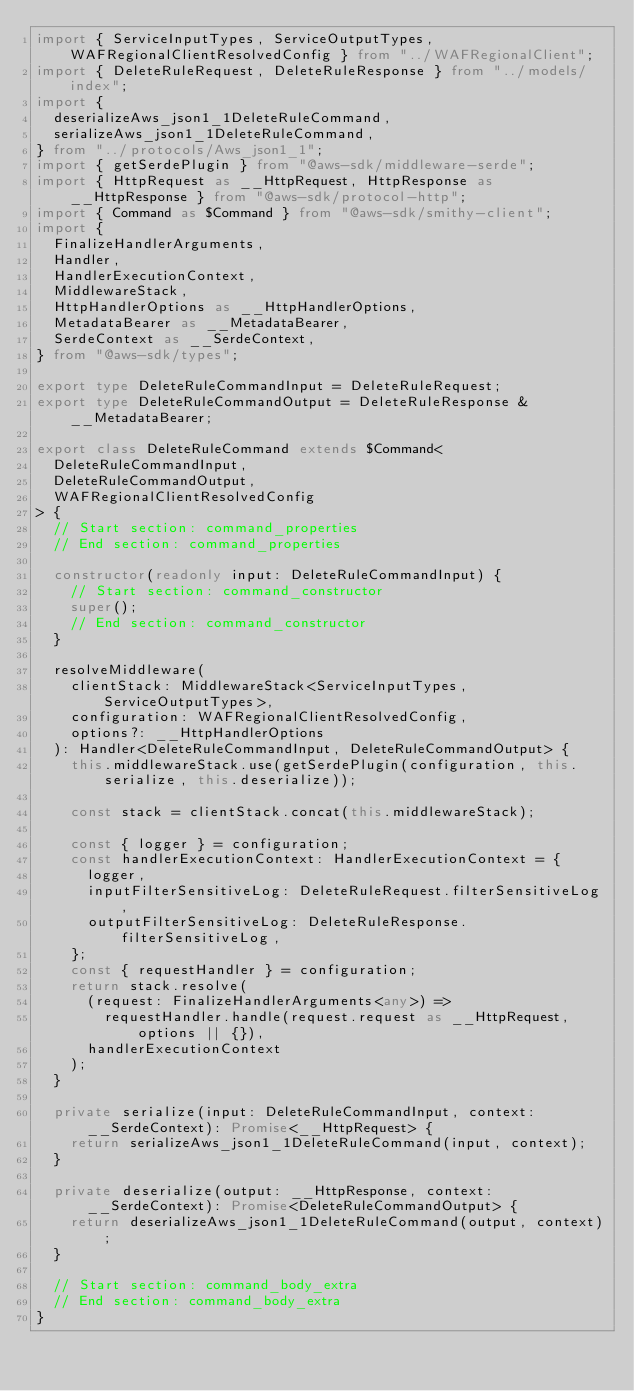<code> <loc_0><loc_0><loc_500><loc_500><_TypeScript_>import { ServiceInputTypes, ServiceOutputTypes, WAFRegionalClientResolvedConfig } from "../WAFRegionalClient";
import { DeleteRuleRequest, DeleteRuleResponse } from "../models/index";
import {
  deserializeAws_json1_1DeleteRuleCommand,
  serializeAws_json1_1DeleteRuleCommand,
} from "../protocols/Aws_json1_1";
import { getSerdePlugin } from "@aws-sdk/middleware-serde";
import { HttpRequest as __HttpRequest, HttpResponse as __HttpResponse } from "@aws-sdk/protocol-http";
import { Command as $Command } from "@aws-sdk/smithy-client";
import {
  FinalizeHandlerArguments,
  Handler,
  HandlerExecutionContext,
  MiddlewareStack,
  HttpHandlerOptions as __HttpHandlerOptions,
  MetadataBearer as __MetadataBearer,
  SerdeContext as __SerdeContext,
} from "@aws-sdk/types";

export type DeleteRuleCommandInput = DeleteRuleRequest;
export type DeleteRuleCommandOutput = DeleteRuleResponse & __MetadataBearer;

export class DeleteRuleCommand extends $Command<
  DeleteRuleCommandInput,
  DeleteRuleCommandOutput,
  WAFRegionalClientResolvedConfig
> {
  // Start section: command_properties
  // End section: command_properties

  constructor(readonly input: DeleteRuleCommandInput) {
    // Start section: command_constructor
    super();
    // End section: command_constructor
  }

  resolveMiddleware(
    clientStack: MiddlewareStack<ServiceInputTypes, ServiceOutputTypes>,
    configuration: WAFRegionalClientResolvedConfig,
    options?: __HttpHandlerOptions
  ): Handler<DeleteRuleCommandInput, DeleteRuleCommandOutput> {
    this.middlewareStack.use(getSerdePlugin(configuration, this.serialize, this.deserialize));

    const stack = clientStack.concat(this.middlewareStack);

    const { logger } = configuration;
    const handlerExecutionContext: HandlerExecutionContext = {
      logger,
      inputFilterSensitiveLog: DeleteRuleRequest.filterSensitiveLog,
      outputFilterSensitiveLog: DeleteRuleResponse.filterSensitiveLog,
    };
    const { requestHandler } = configuration;
    return stack.resolve(
      (request: FinalizeHandlerArguments<any>) =>
        requestHandler.handle(request.request as __HttpRequest, options || {}),
      handlerExecutionContext
    );
  }

  private serialize(input: DeleteRuleCommandInput, context: __SerdeContext): Promise<__HttpRequest> {
    return serializeAws_json1_1DeleteRuleCommand(input, context);
  }

  private deserialize(output: __HttpResponse, context: __SerdeContext): Promise<DeleteRuleCommandOutput> {
    return deserializeAws_json1_1DeleteRuleCommand(output, context);
  }

  // Start section: command_body_extra
  // End section: command_body_extra
}
</code> 